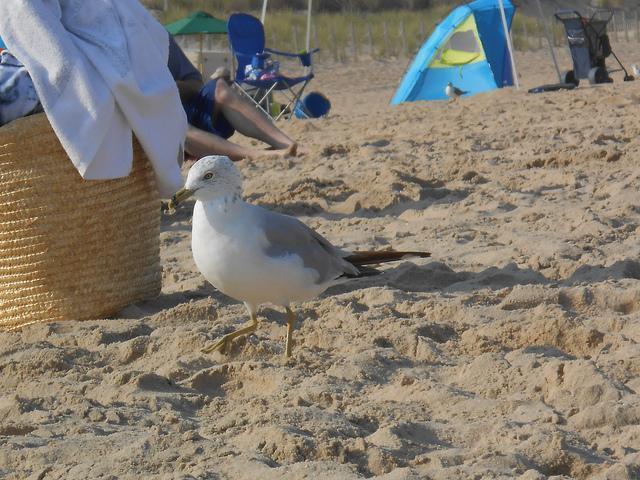How many birds are there?
Give a very brief answer. 1. How many bears are pictured?
Give a very brief answer. 0. 